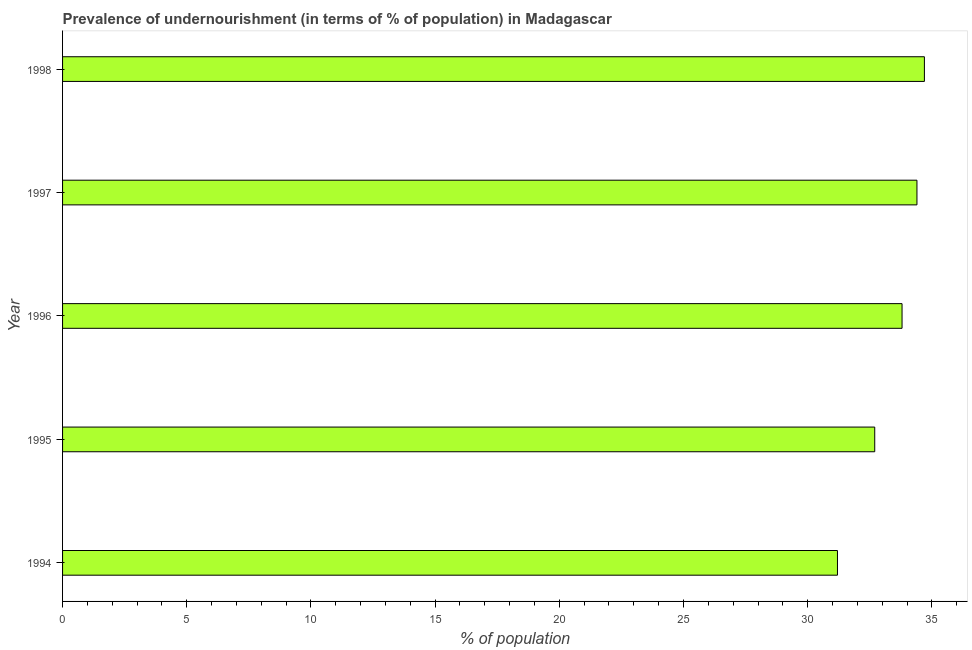Does the graph contain any zero values?
Your answer should be very brief. No. Does the graph contain grids?
Keep it short and to the point. No. What is the title of the graph?
Keep it short and to the point. Prevalence of undernourishment (in terms of % of population) in Madagascar. What is the label or title of the X-axis?
Offer a terse response. % of population. What is the label or title of the Y-axis?
Offer a terse response. Year. What is the percentage of undernourished population in 1994?
Offer a terse response. 31.2. Across all years, what is the maximum percentage of undernourished population?
Your response must be concise. 34.7. Across all years, what is the minimum percentage of undernourished population?
Your answer should be compact. 31.2. In which year was the percentage of undernourished population maximum?
Offer a terse response. 1998. What is the sum of the percentage of undernourished population?
Offer a very short reply. 166.8. What is the difference between the percentage of undernourished population in 1995 and 1998?
Provide a succinct answer. -2. What is the average percentage of undernourished population per year?
Ensure brevity in your answer.  33.36. What is the median percentage of undernourished population?
Your answer should be compact. 33.8. In how many years, is the percentage of undernourished population greater than 14 %?
Provide a succinct answer. 5. Do a majority of the years between 1998 and 1996 (inclusive) have percentage of undernourished population greater than 32 %?
Give a very brief answer. Yes. What is the ratio of the percentage of undernourished population in 1994 to that in 1998?
Your response must be concise. 0.9. Is the percentage of undernourished population in 1996 less than that in 1998?
Offer a very short reply. Yes. What is the difference between the highest and the second highest percentage of undernourished population?
Offer a terse response. 0.3. What is the difference between the highest and the lowest percentage of undernourished population?
Make the answer very short. 3.5. Are all the bars in the graph horizontal?
Keep it short and to the point. Yes. How many years are there in the graph?
Your response must be concise. 5. What is the % of population in 1994?
Offer a terse response. 31.2. What is the % of population in 1995?
Give a very brief answer. 32.7. What is the % of population of 1996?
Your answer should be very brief. 33.8. What is the % of population in 1997?
Give a very brief answer. 34.4. What is the % of population in 1998?
Provide a short and direct response. 34.7. What is the difference between the % of population in 1994 and 1995?
Offer a very short reply. -1.5. What is the difference between the % of population in 1994 and 1996?
Your answer should be very brief. -2.6. What is the difference between the % of population in 1995 and 1997?
Keep it short and to the point. -1.7. What is the difference between the % of population in 1996 and 1997?
Make the answer very short. -0.6. What is the ratio of the % of population in 1994 to that in 1995?
Give a very brief answer. 0.95. What is the ratio of the % of population in 1994 to that in 1996?
Give a very brief answer. 0.92. What is the ratio of the % of population in 1994 to that in 1997?
Make the answer very short. 0.91. What is the ratio of the % of population in 1994 to that in 1998?
Provide a succinct answer. 0.9. What is the ratio of the % of population in 1995 to that in 1996?
Offer a terse response. 0.97. What is the ratio of the % of population in 1995 to that in 1997?
Offer a terse response. 0.95. What is the ratio of the % of population in 1995 to that in 1998?
Offer a very short reply. 0.94. What is the ratio of the % of population in 1996 to that in 1997?
Your answer should be compact. 0.98. What is the ratio of the % of population in 1996 to that in 1998?
Offer a very short reply. 0.97. What is the ratio of the % of population in 1997 to that in 1998?
Ensure brevity in your answer.  0.99. 